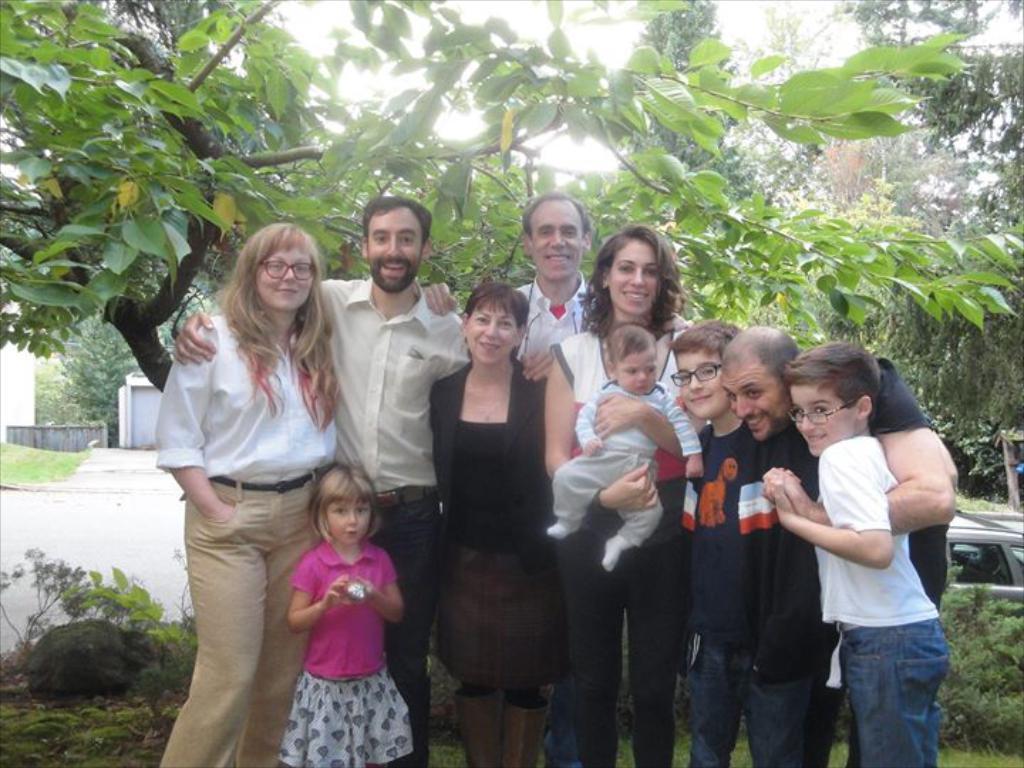How would you summarize this image in a sentence or two? In this image there are group of people standing and one woman is holding a baby, and in the background there are trees, houses, wall. At the bottom there are some plants and grass. 